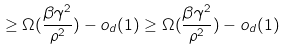<formula> <loc_0><loc_0><loc_500><loc_500>\geq \Omega ( \frac { \beta \gamma ^ { 2 } } { \rho ^ { 2 } } ) - o _ { d } ( 1 ) \geq \Omega ( \frac { \beta \gamma ^ { 2 } } { \rho ^ { 2 } } ) - o _ { d } ( 1 )</formula> 